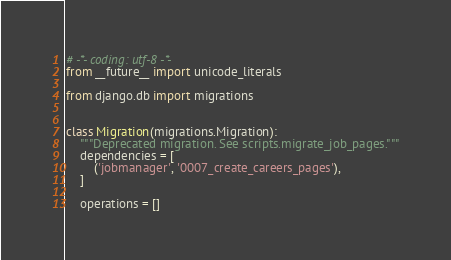Convert code to text. <code><loc_0><loc_0><loc_500><loc_500><_Python_># -*- coding: utf-8 -*-
from __future__ import unicode_literals

from django.db import migrations


class Migration(migrations.Migration):
    """Deprecated migration. See scripts.migrate_job_pages."""
    dependencies = [
        ('jobmanager', '0007_create_careers_pages'),
    ]

    operations = []
</code> 